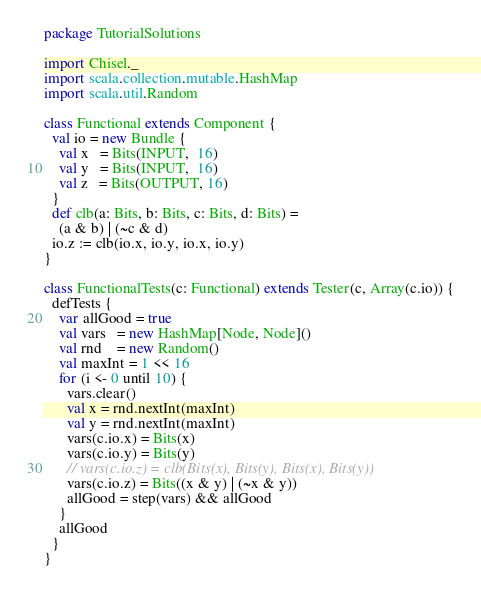<code> <loc_0><loc_0><loc_500><loc_500><_Scala_>package TutorialSolutions

import Chisel._
import scala.collection.mutable.HashMap
import scala.util.Random

class Functional extends Component {
  val io = new Bundle {
    val x   = Bits(INPUT,  16)
    val y   = Bits(INPUT,  16)
    val z   = Bits(OUTPUT, 16)
  }
  def clb(a: Bits, b: Bits, c: Bits, d: Bits) =
    (a & b) | (~c & d)
  io.z := clb(io.x, io.y, io.x, io.y)
}

class FunctionalTests(c: Functional) extends Tester(c, Array(c.io)) {
  defTests {
    var allGood = true
    val vars   = new HashMap[Node, Node]()
    val rnd    = new Random()
    val maxInt = 1 << 16
    for (i <- 0 until 10) {
      vars.clear()
      val x = rnd.nextInt(maxInt)
      val y = rnd.nextInt(maxInt)
      vars(c.io.x) = Bits(x)
      vars(c.io.y) = Bits(y)
      // vars(c.io.z) = clb(Bits(x), Bits(y), Bits(x), Bits(y))
      vars(c.io.z) = Bits((x & y) | (~x & y))
      allGood = step(vars) && allGood
    }
    allGood
  }
}
</code> 